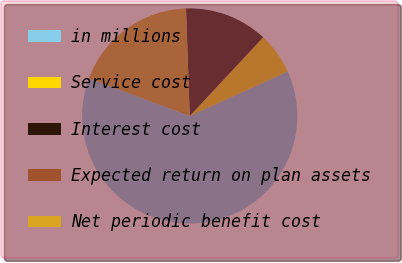<chart> <loc_0><loc_0><loc_500><loc_500><pie_chart><fcel>in millions<fcel>Service cost<fcel>Interest cost<fcel>Expected return on plan assets<fcel>Net periodic benefit cost<nl><fcel>62.47%<fcel>6.26%<fcel>12.5%<fcel>0.01%<fcel>18.75%<nl></chart> 